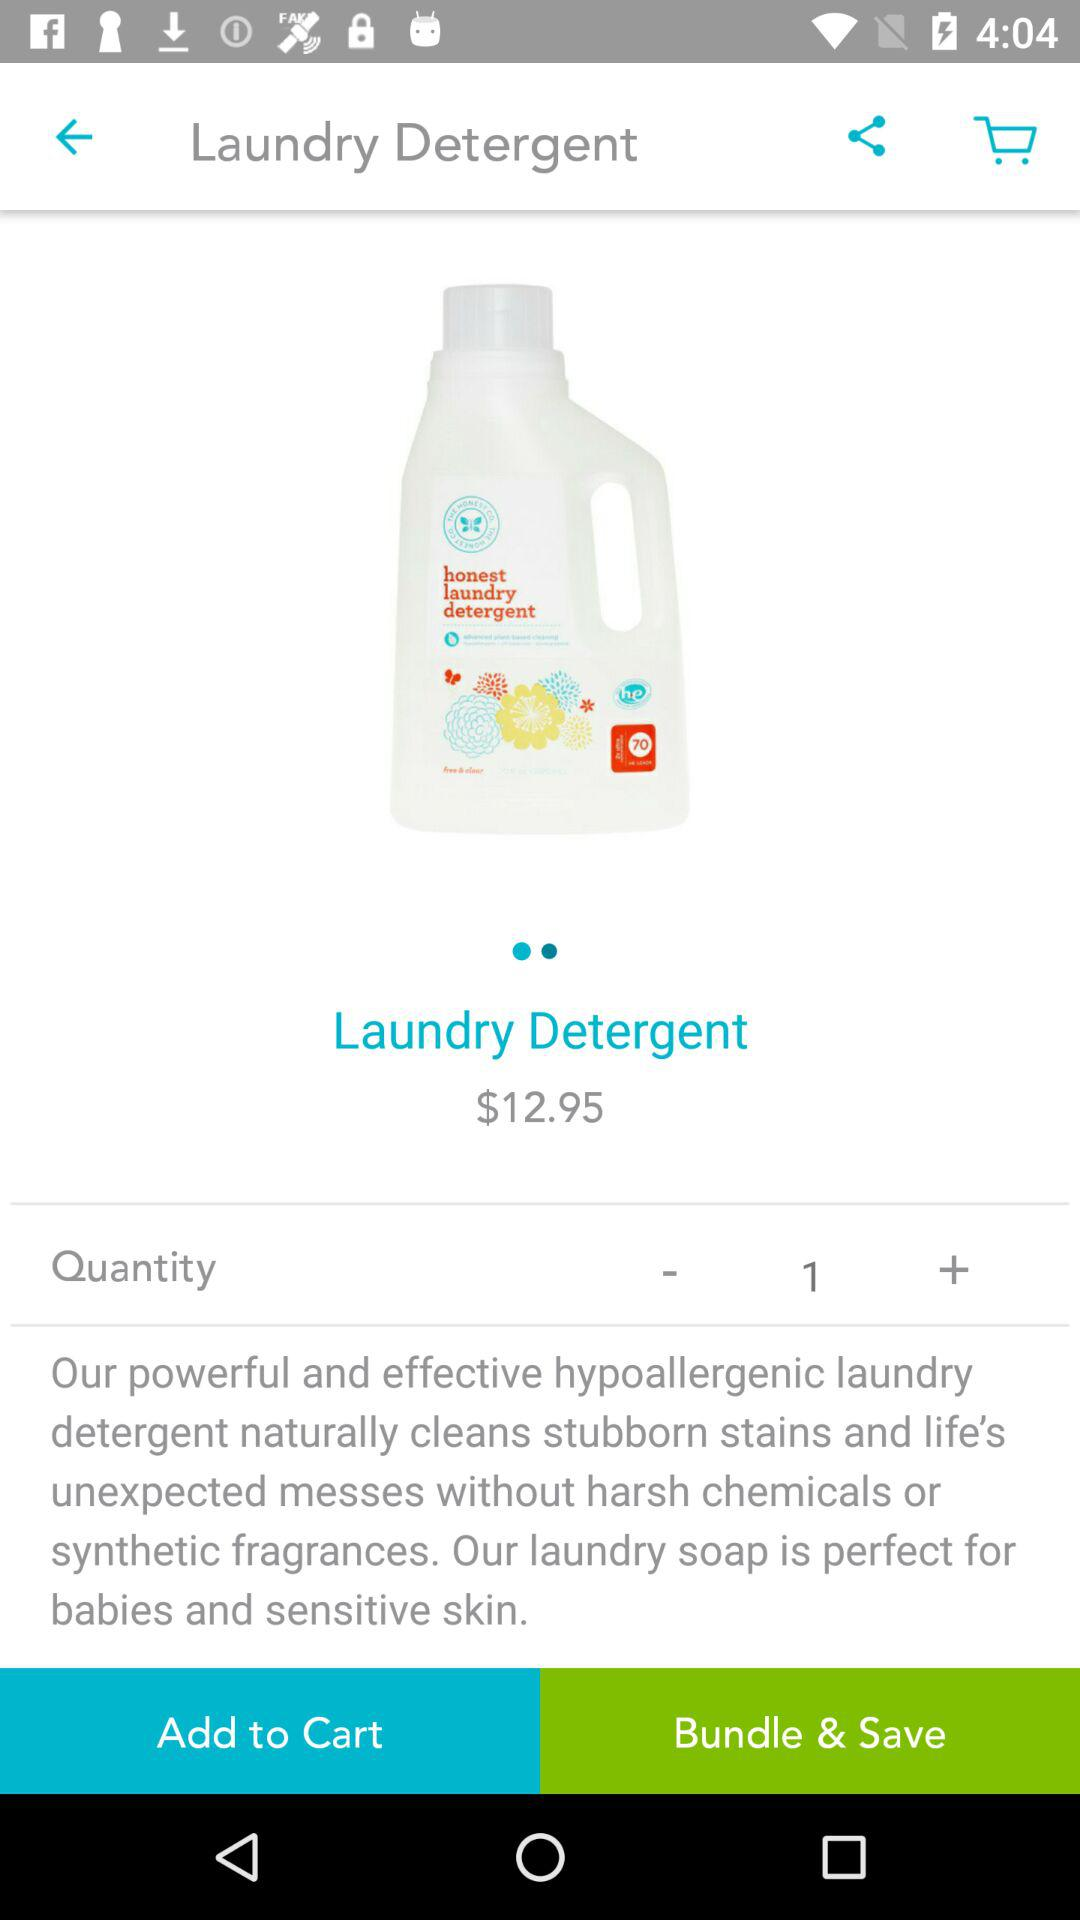How many items are in the cart?
When the provided information is insufficient, respond with <no answer>. <no answer> 